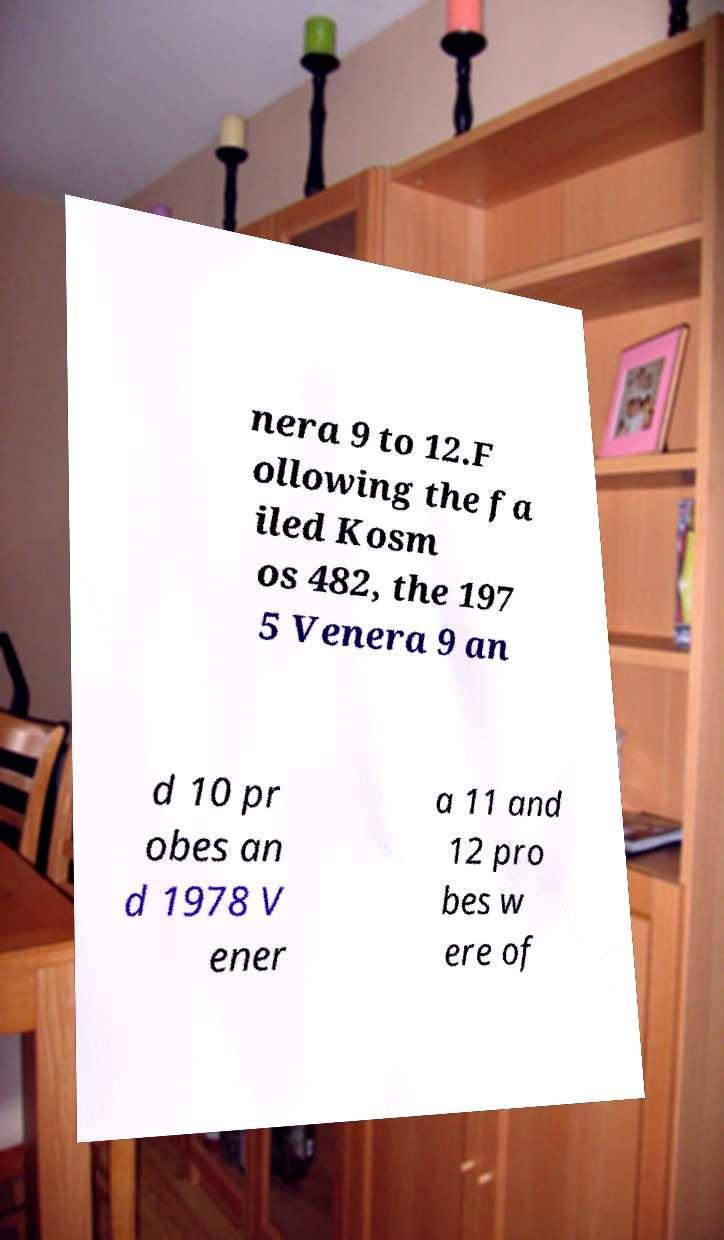Can you accurately transcribe the text from the provided image for me? nera 9 to 12.F ollowing the fa iled Kosm os 482, the 197 5 Venera 9 an d 10 pr obes an d 1978 V ener a 11 and 12 pro bes w ere of 